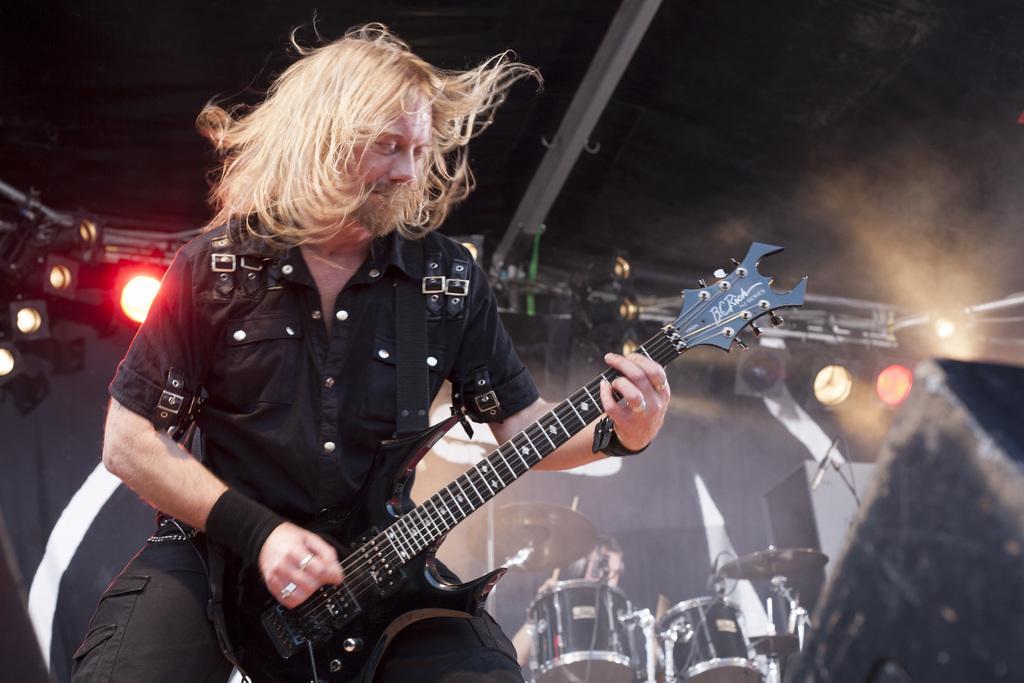Could you give a brief overview of what you see in this image? In this image ,there is a man he wear black shirt and trouser , he is playing guitar. In the background there are drums,a person ,lights and speaker. 